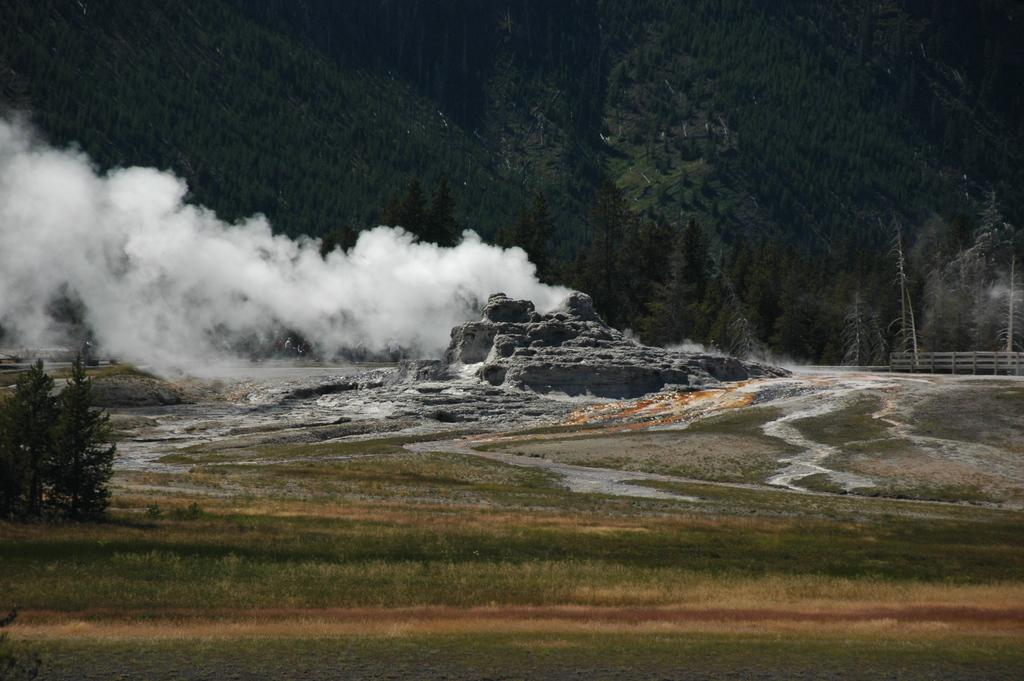What type of vegetation can be seen in the image? There is grass and trees in the image. What other objects can be seen in the image? There is a plant, stones, smoke, and a fence in the image. What disease is affecting the plant in the image? There is no indication of any disease affecting the plant in the image. What does the plant need to grow in the image? The image does not provide information about the plant's needs for growth. 